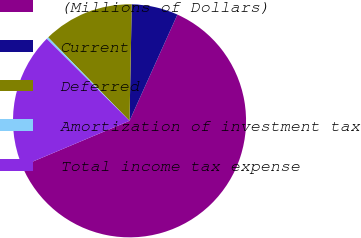<chart> <loc_0><loc_0><loc_500><loc_500><pie_chart><fcel>(Millions of Dollars)<fcel>Current<fcel>Deferred<fcel>Amortization of investment tax<fcel>Total income tax expense<nl><fcel>61.91%<fcel>6.44%<fcel>12.6%<fcel>0.28%<fcel>18.77%<nl></chart> 